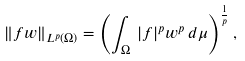<formula> <loc_0><loc_0><loc_500><loc_500>\| f w \| _ { L ^ { p } ( \Omega ) } = \left ( \int _ { \Omega } \, | f | ^ { p } w ^ { p } \, d \mu \right ) ^ { \frac { 1 } { p } } ,</formula> 